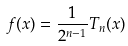Convert formula to latex. <formula><loc_0><loc_0><loc_500><loc_500>f ( x ) = \frac { 1 } { 2 ^ { n - 1 } } T _ { n } ( x )</formula> 